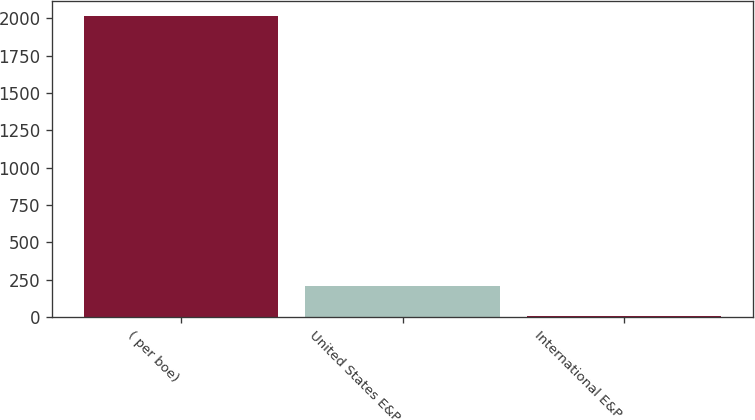<chart> <loc_0><loc_0><loc_500><loc_500><bar_chart><fcel>( per boe)<fcel>United States E&P<fcel>International E&P<nl><fcel>2015<fcel>207.75<fcel>6.95<nl></chart> 